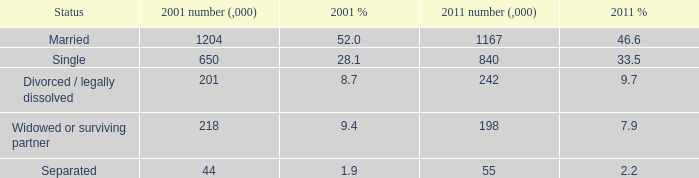What si the 2011 number (,000) when 2001 % is 28.1? 840.0. 